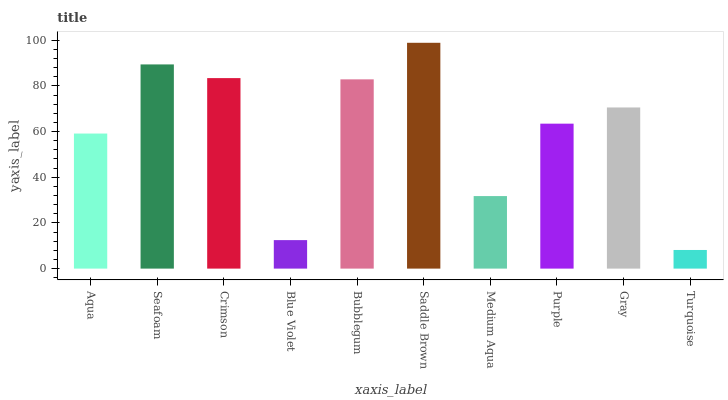Is Turquoise the minimum?
Answer yes or no. Yes. Is Saddle Brown the maximum?
Answer yes or no. Yes. Is Seafoam the minimum?
Answer yes or no. No. Is Seafoam the maximum?
Answer yes or no. No. Is Seafoam greater than Aqua?
Answer yes or no. Yes. Is Aqua less than Seafoam?
Answer yes or no. Yes. Is Aqua greater than Seafoam?
Answer yes or no. No. Is Seafoam less than Aqua?
Answer yes or no. No. Is Gray the high median?
Answer yes or no. Yes. Is Purple the low median?
Answer yes or no. Yes. Is Bubblegum the high median?
Answer yes or no. No. Is Aqua the low median?
Answer yes or no. No. 